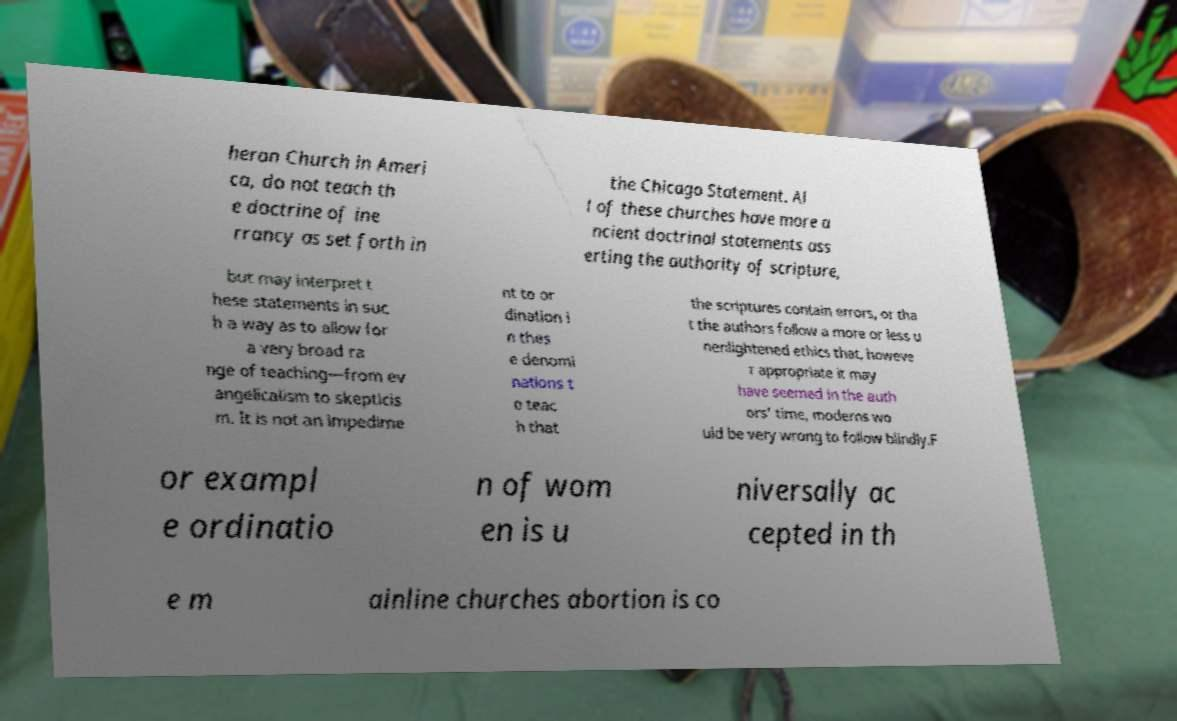For documentation purposes, I need the text within this image transcribed. Could you provide that? heran Church in Ameri ca, do not teach th e doctrine of ine rrancy as set forth in the Chicago Statement. Al l of these churches have more a ncient doctrinal statements ass erting the authority of scripture, but may interpret t hese statements in suc h a way as to allow for a very broad ra nge of teaching—from ev angelicalism to skepticis m. It is not an impedime nt to or dination i n thes e denomi nations t o teac h that the scriptures contain errors, or tha t the authors follow a more or less u nenlightened ethics that, howeve r appropriate it may have seemed in the auth ors' time, moderns wo uld be very wrong to follow blindly.F or exampl e ordinatio n of wom en is u niversally ac cepted in th e m ainline churches abortion is co 